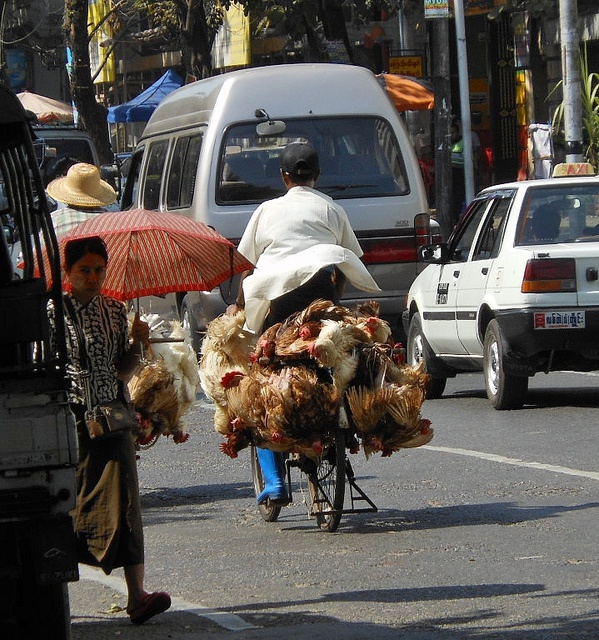Describe the objects in this image and their specific colors. I can see car in black, ivory, gray, and darkgray tones, people in black, maroon, and gray tones, umbrella in black, maroon, brown, and lightpink tones, people in black, white, darkgray, and gray tones, and bird in black, maroon, and gray tones in this image. 